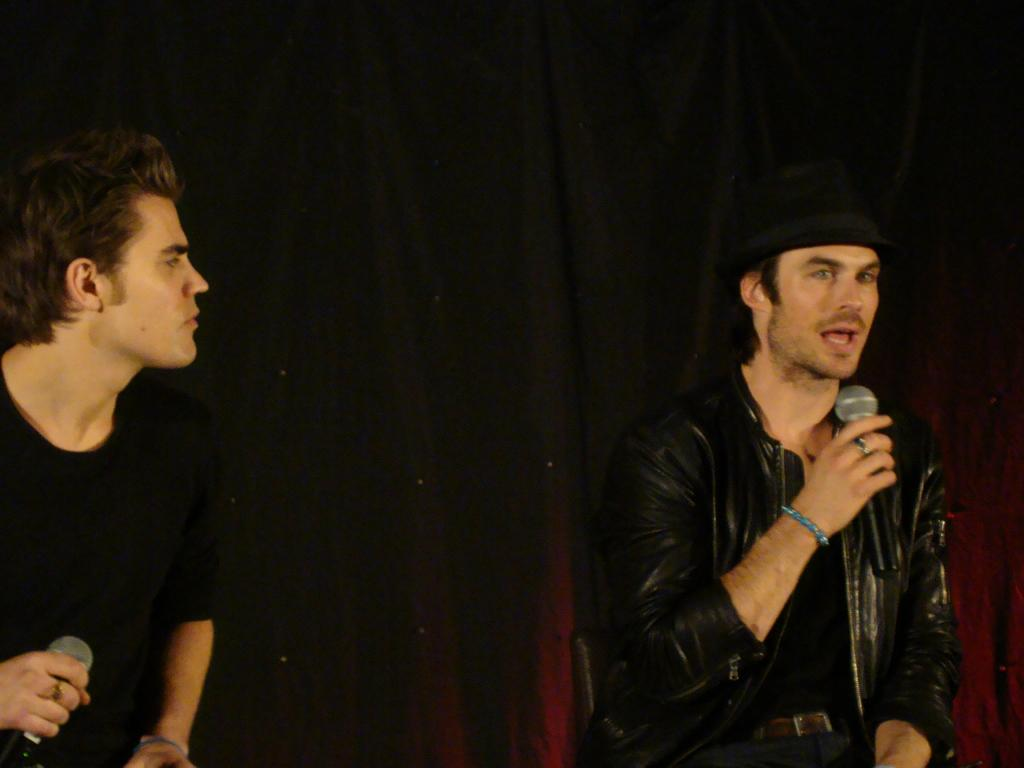How many people are in the image? There are two men in the image. What are the two men holding in the image? The two men are holding a microphone. What type of coast can be seen in the image? There is no coast visible in the image; it features two men holding a microphone. Is there a letter being passed between the two men in the image? There is no letter present in the image; the two men are holding a microphone. 